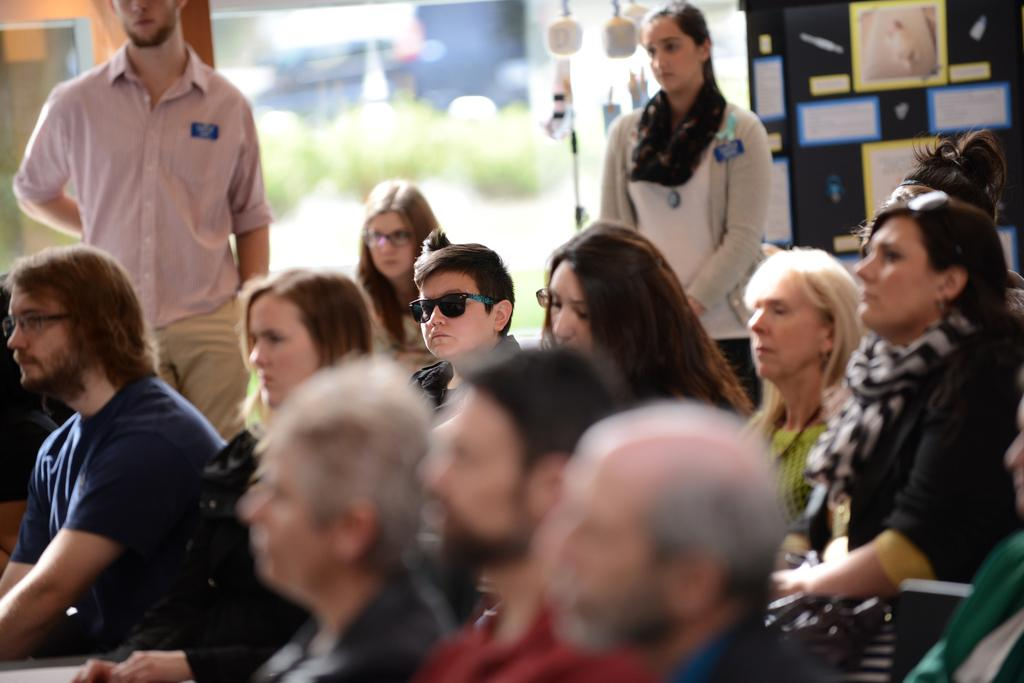Who or what is present in the image? There are people in the image. What can be seen on the boards with text? The boards have text in the image. What is the tall, vertical object in the image? There is a pole in the image. What color are the objects that stand out in the image? There are white colored objects in the image. How would you describe the background of the image? The background of the image is blurred. What type of doll is sitting on the note in the image? There is no doll or note present in the image. 